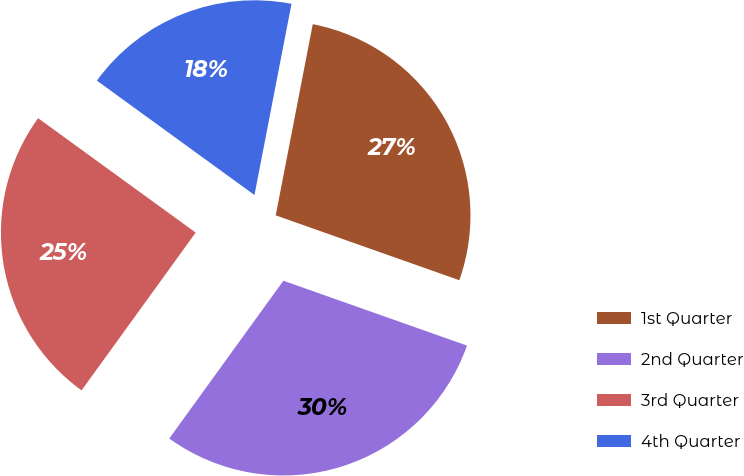<chart> <loc_0><loc_0><loc_500><loc_500><pie_chart><fcel>1st Quarter<fcel>2nd Quarter<fcel>3rd Quarter<fcel>4th Quarter<nl><fcel>27.36%<fcel>29.56%<fcel>25.03%<fcel>18.05%<nl></chart> 